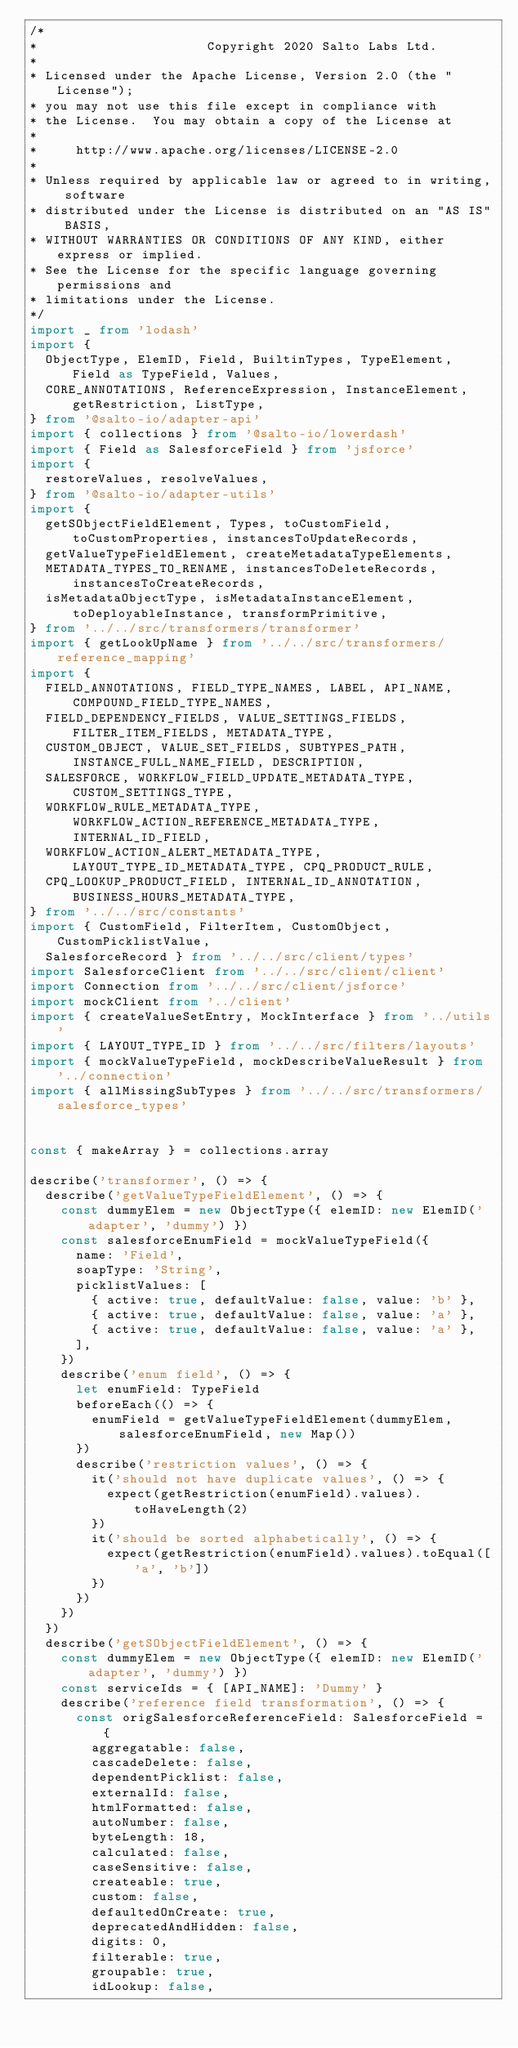<code> <loc_0><loc_0><loc_500><loc_500><_TypeScript_>/*
*                      Copyright 2020 Salto Labs Ltd.
*
* Licensed under the Apache License, Version 2.0 (the "License");
* you may not use this file except in compliance with
* the License.  You may obtain a copy of the License at
*
*     http://www.apache.org/licenses/LICENSE-2.0
*
* Unless required by applicable law or agreed to in writing, software
* distributed under the License is distributed on an "AS IS" BASIS,
* WITHOUT WARRANTIES OR CONDITIONS OF ANY KIND, either express or implied.
* See the License for the specific language governing permissions and
* limitations under the License.
*/
import _ from 'lodash'
import {
  ObjectType, ElemID, Field, BuiltinTypes, TypeElement, Field as TypeField, Values,
  CORE_ANNOTATIONS, ReferenceExpression, InstanceElement, getRestriction, ListType,
} from '@salto-io/adapter-api'
import { collections } from '@salto-io/lowerdash'
import { Field as SalesforceField } from 'jsforce'
import {
  restoreValues, resolveValues,
} from '@salto-io/adapter-utils'
import {
  getSObjectFieldElement, Types, toCustomField, toCustomProperties, instancesToUpdateRecords,
  getValueTypeFieldElement, createMetadataTypeElements,
  METADATA_TYPES_TO_RENAME, instancesToDeleteRecords, instancesToCreateRecords,
  isMetadataObjectType, isMetadataInstanceElement, toDeployableInstance, transformPrimitive,
} from '../../src/transformers/transformer'
import { getLookUpName } from '../../src/transformers/reference_mapping'
import {
  FIELD_ANNOTATIONS, FIELD_TYPE_NAMES, LABEL, API_NAME, COMPOUND_FIELD_TYPE_NAMES,
  FIELD_DEPENDENCY_FIELDS, VALUE_SETTINGS_FIELDS, FILTER_ITEM_FIELDS, METADATA_TYPE,
  CUSTOM_OBJECT, VALUE_SET_FIELDS, SUBTYPES_PATH, INSTANCE_FULL_NAME_FIELD, DESCRIPTION,
  SALESFORCE, WORKFLOW_FIELD_UPDATE_METADATA_TYPE, CUSTOM_SETTINGS_TYPE,
  WORKFLOW_RULE_METADATA_TYPE, WORKFLOW_ACTION_REFERENCE_METADATA_TYPE, INTERNAL_ID_FIELD,
  WORKFLOW_ACTION_ALERT_METADATA_TYPE, LAYOUT_TYPE_ID_METADATA_TYPE, CPQ_PRODUCT_RULE,
  CPQ_LOOKUP_PRODUCT_FIELD, INTERNAL_ID_ANNOTATION, BUSINESS_HOURS_METADATA_TYPE,
} from '../../src/constants'
import { CustomField, FilterItem, CustomObject, CustomPicklistValue,
  SalesforceRecord } from '../../src/client/types'
import SalesforceClient from '../../src/client/client'
import Connection from '../../src/client/jsforce'
import mockClient from '../client'
import { createValueSetEntry, MockInterface } from '../utils'
import { LAYOUT_TYPE_ID } from '../../src/filters/layouts'
import { mockValueTypeField, mockDescribeValueResult } from '../connection'
import { allMissingSubTypes } from '../../src/transformers/salesforce_types'


const { makeArray } = collections.array

describe('transformer', () => {
  describe('getValueTypeFieldElement', () => {
    const dummyElem = new ObjectType({ elemID: new ElemID('adapter', 'dummy') })
    const salesforceEnumField = mockValueTypeField({
      name: 'Field',
      soapType: 'String',
      picklistValues: [
        { active: true, defaultValue: false, value: 'b' },
        { active: true, defaultValue: false, value: 'a' },
        { active: true, defaultValue: false, value: 'a' },
      ],
    })
    describe('enum field', () => {
      let enumField: TypeField
      beforeEach(() => {
        enumField = getValueTypeFieldElement(dummyElem, salesforceEnumField, new Map())
      })
      describe('restriction values', () => {
        it('should not have duplicate values', () => {
          expect(getRestriction(enumField).values).toHaveLength(2)
        })
        it('should be sorted alphabetically', () => {
          expect(getRestriction(enumField).values).toEqual(['a', 'b'])
        })
      })
    })
  })
  describe('getSObjectFieldElement', () => {
    const dummyElem = new ObjectType({ elemID: new ElemID('adapter', 'dummy') })
    const serviceIds = { [API_NAME]: 'Dummy' }
    describe('reference field transformation', () => {
      const origSalesforceReferenceField: SalesforceField = {
        aggregatable: false,
        cascadeDelete: false,
        dependentPicklist: false,
        externalId: false,
        htmlFormatted: false,
        autoNumber: false,
        byteLength: 18,
        calculated: false,
        caseSensitive: false,
        createable: true,
        custom: false,
        defaultedOnCreate: true,
        deprecatedAndHidden: false,
        digits: 0,
        filterable: true,
        groupable: true,
        idLookup: false,</code> 